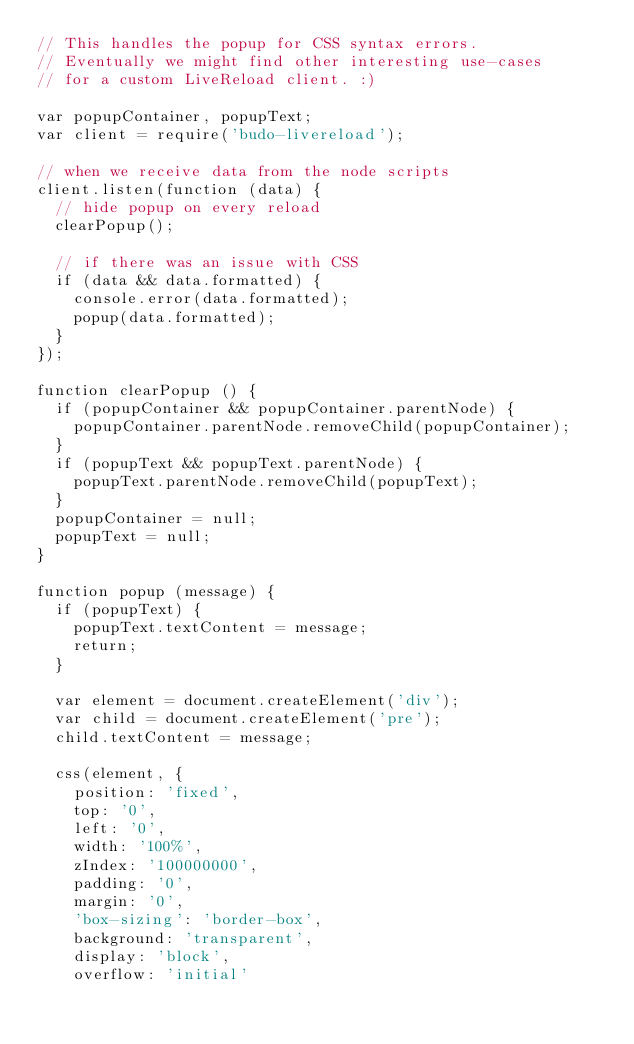Convert code to text. <code><loc_0><loc_0><loc_500><loc_500><_JavaScript_>// This handles the popup for CSS syntax errors.
// Eventually we might find other interesting use-cases
// for a custom LiveReload client. :)

var popupContainer, popupText;
var client = require('budo-livereload');

// when we receive data from the node scripts
client.listen(function (data) {
  // hide popup on every reload
  clearPopup();

  // if there was an issue with CSS
  if (data && data.formatted) {
    console.error(data.formatted);
    popup(data.formatted);
  }
});

function clearPopup () {
  if (popupContainer && popupContainer.parentNode) {
    popupContainer.parentNode.removeChild(popupContainer);
  }
  if (popupText && popupText.parentNode) {
    popupText.parentNode.removeChild(popupText);
  }
  popupContainer = null;
  popupText = null;
}

function popup (message) {
  if (popupText) {
    popupText.textContent = message;
    return;
  }

  var element = document.createElement('div');
  var child = document.createElement('pre');
  child.textContent = message;

  css(element, {
    position: 'fixed',
    top: '0',
    left: '0',
    width: '100%',
    zIndex: '100000000',
    padding: '0',
    margin: '0',
    'box-sizing': 'border-box',
    background: 'transparent',
    display: 'block',
    overflow: 'initial'</code> 